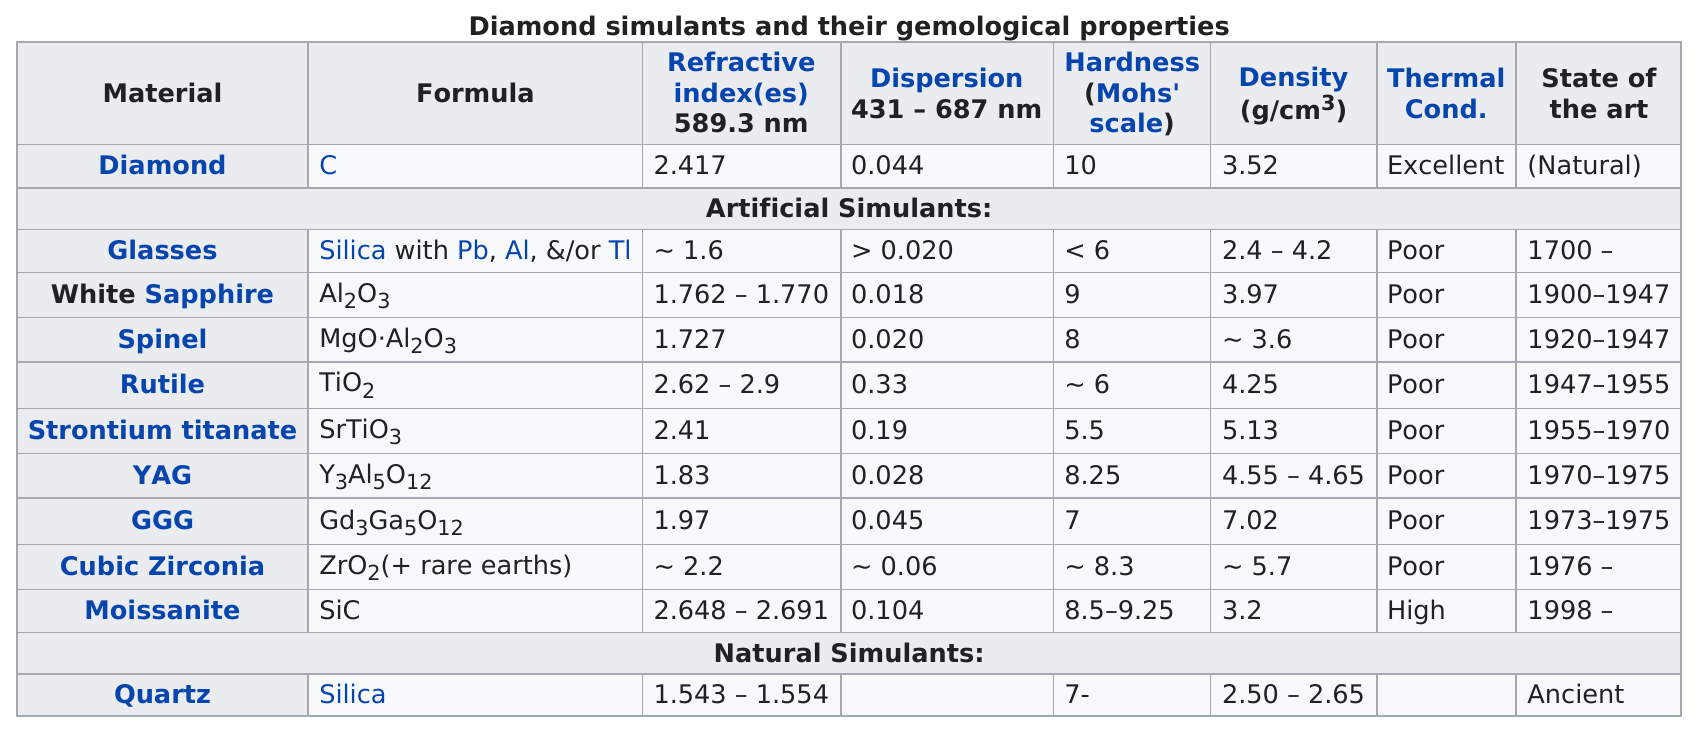Point out several critical features in this image. Rutile was discovered after quartz. The number of atoms in one molecule of yag is 20. White Sapphire has a dispersion of approximately .018 nanometers. The hardness of a diamond is approximately 10 on the Mohs scale. Moissanite has a thermal condition that is less than excellent but more than poor. 